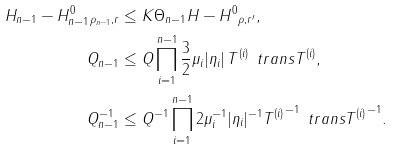<formula> <loc_0><loc_0><loc_500><loc_500>\| H _ { n - 1 } - H _ { n - 1 } ^ { 0 } \| _ { \rho _ { n - 1 } , r } & \leq K \Theta _ { n - 1 } \| H - H ^ { 0 } \| _ { \rho , r ^ { \prime } } , \\ \| Q _ { n - 1 } \| & \leq \| Q \| \prod _ { i = 1 } ^ { n - 1 } \frac { 3 } { 2 } \mu _ { i } | \eta _ { i } | \, \| T ^ { ( i ) } \| \, \| \ t r a n s T ^ { ( i ) } \| , \\ \| Q _ { n - 1 } ^ { - 1 } \| & \leq \| Q ^ { - 1 } \| \prod _ { i = 1 } ^ { n - 1 } 2 \mu _ { i } ^ { - 1 } | \eta _ { i } | ^ { - 1 } \| { T ^ { ( i ) } } ^ { - 1 } \| \, \| \ t r a n s { T ^ { ( i ) } } ^ { - 1 } \| .</formula> 